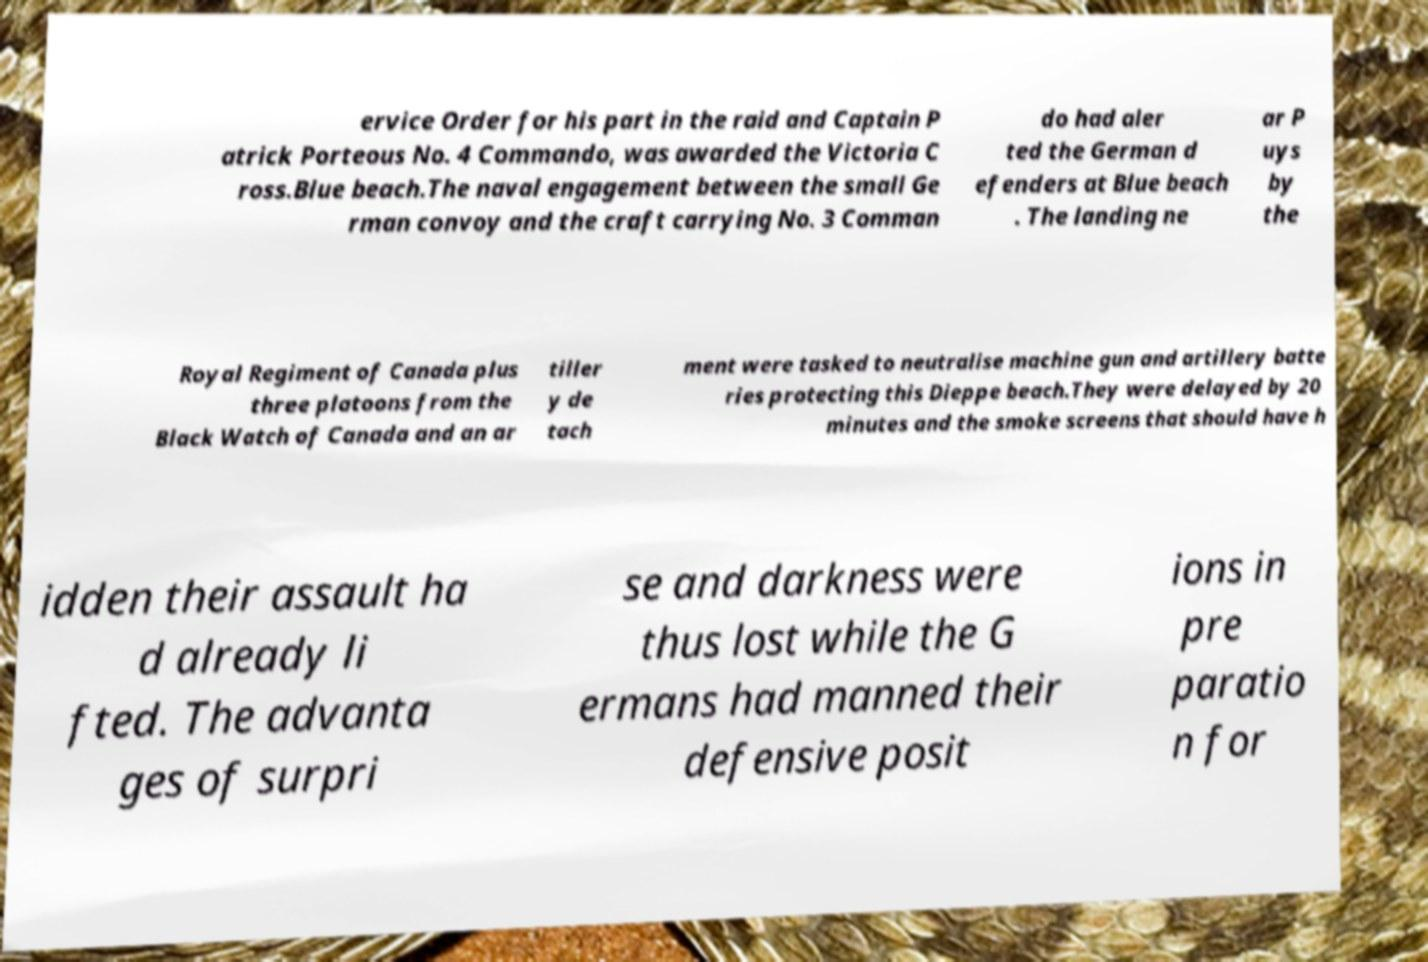Please identify and transcribe the text found in this image. ervice Order for his part in the raid and Captain P atrick Porteous No. 4 Commando, was awarded the Victoria C ross.Blue beach.The naval engagement between the small Ge rman convoy and the craft carrying No. 3 Comman do had aler ted the German d efenders at Blue beach . The landing ne ar P uys by the Royal Regiment of Canada plus three platoons from the Black Watch of Canada and an ar tiller y de tach ment were tasked to neutralise machine gun and artillery batte ries protecting this Dieppe beach.They were delayed by 20 minutes and the smoke screens that should have h idden their assault ha d already li fted. The advanta ges of surpri se and darkness were thus lost while the G ermans had manned their defensive posit ions in pre paratio n for 